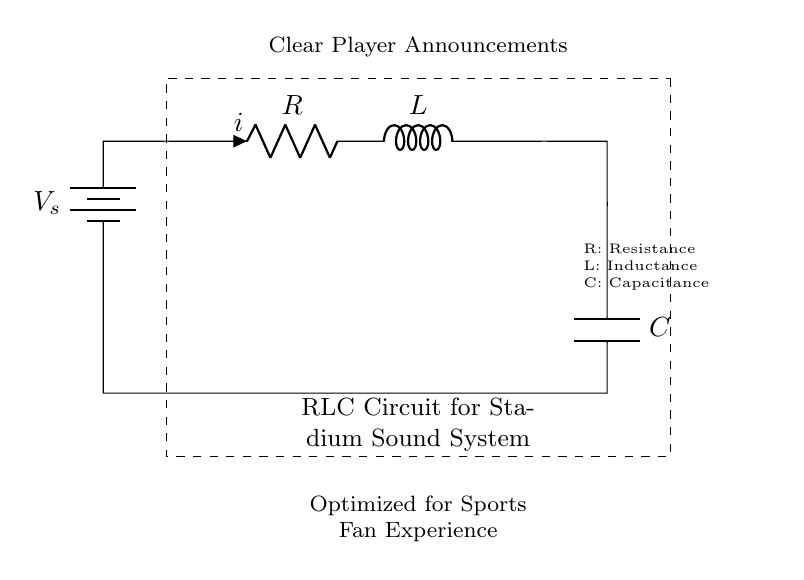What are the components in this circuit? The visual shows a resistor, an inductor, and a capacitor, along with a voltage source. Each component is clearly labeled in the diagram.
Answer: Resistor, Inductor, Capacitor What does the voltage symbol represent in the circuit? The circuit features a label for a voltage source (V_s), which provides the electrical potential necessary for the operation of the circuit.
Answer: Voltage source What is the role of R in this RLC circuit? The resistor (R) controls the current flow and dissipates energy as heat, affecting the overall performance of the circuit in terms of attenuation and damping.
Answer: Current control How does the inductor (L) affect the circuit? The inductor (L) stores energy in a magnetic field when current flows through it, and it affects the phase relationship between voltage and current in the circuit, which is crucial for audio quality.
Answer: Energy storage What is the purpose of the capacitor (C) in the circuit? The capacitor (C) stores energy in an electric field and can influence the frequency response of the sound system, enhancing the clarity of player announcements.
Answer: Frequency response How do R, L, and C work together in this RLC circuit? The resistor, inductor, and capacitor interact to create a resonant circuit that can filter specific frequencies, allowing for clearer announcements tailored to the stadium environment. Their values determine the resonant frequency and damping characteristics of the circuit.
Answer: Resonant circuit What type of circuit is this? The circuit shown is specifically an RLC circuit, which utilizes a resistor, inductor, and capacitor to manage audio signals in sound systems, particularly for clarity during player announcements.
Answer: RLC circuit 